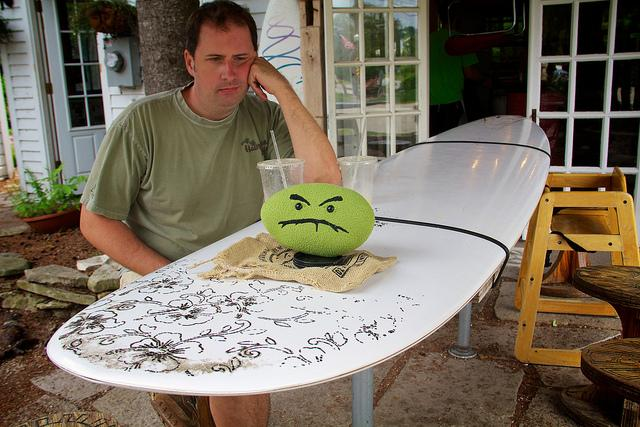What facial expression is the green ball showing?

Choices:
A) fear
B) anger
C) happiness
D) confusion anger 